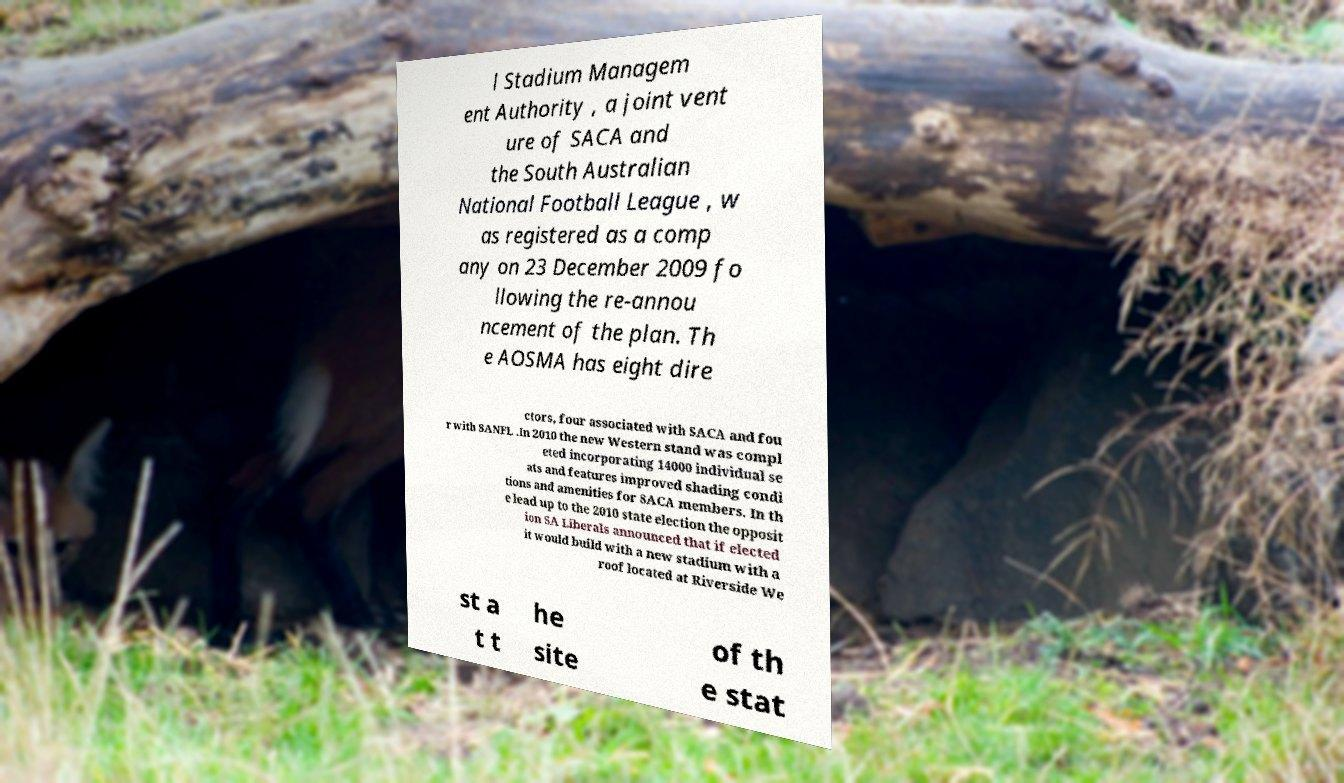I need the written content from this picture converted into text. Can you do that? l Stadium Managem ent Authority , a joint vent ure of SACA and the South Australian National Football League , w as registered as a comp any on 23 December 2009 fo llowing the re-annou ncement of the plan. Th e AOSMA has eight dire ctors, four associated with SACA and fou r with SANFL .In 2010 the new Western stand was compl eted incorporating 14000 individual se ats and features improved shading condi tions and amenities for SACA members. In th e lead up to the 2010 state election the opposit ion SA Liberals announced that if elected it would build with a new stadium with a roof located at Riverside We st a t t he site of th e stat 